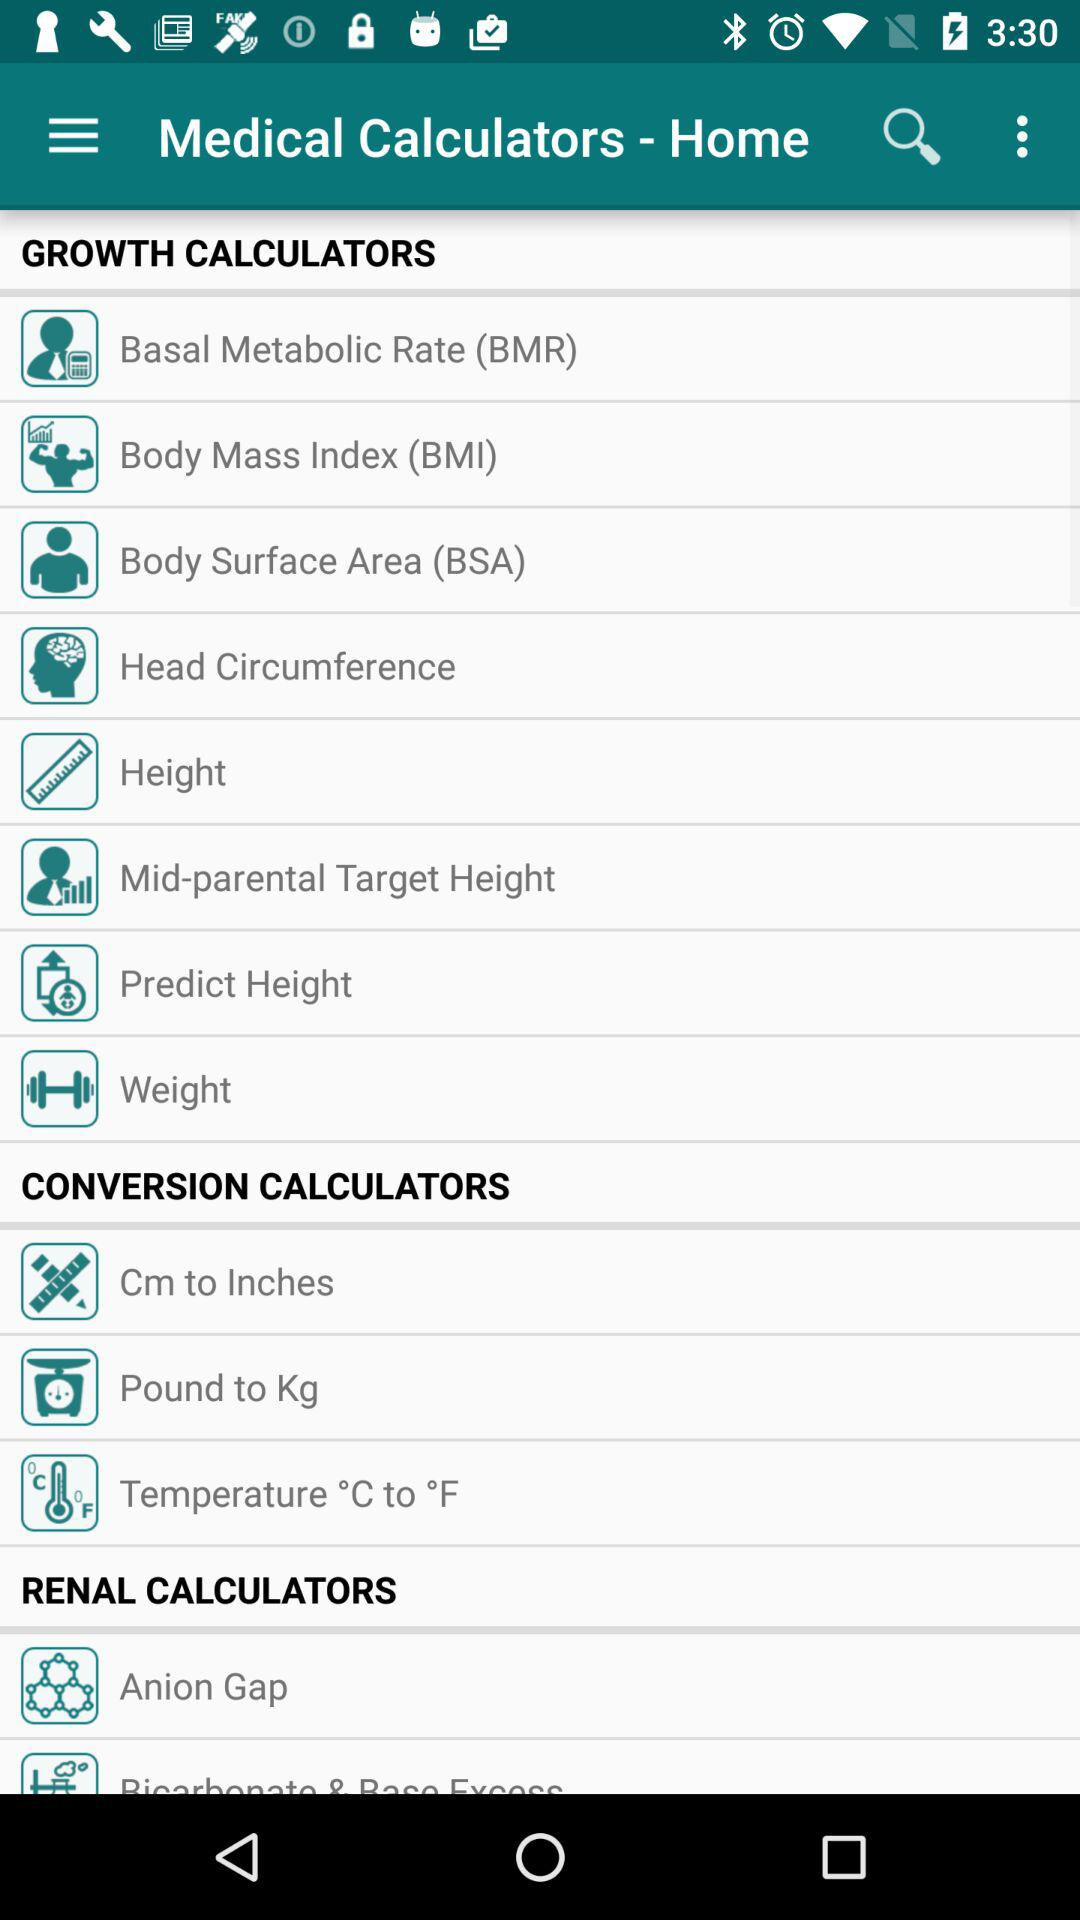What is the name of the application? The name of the application is "Medical Calculators ". 